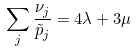<formula> <loc_0><loc_0><loc_500><loc_500>\sum _ { j } \frac { \nu _ { j } } { \tilde { p } _ { j } } = 4 \lambda + 3 \mu</formula> 